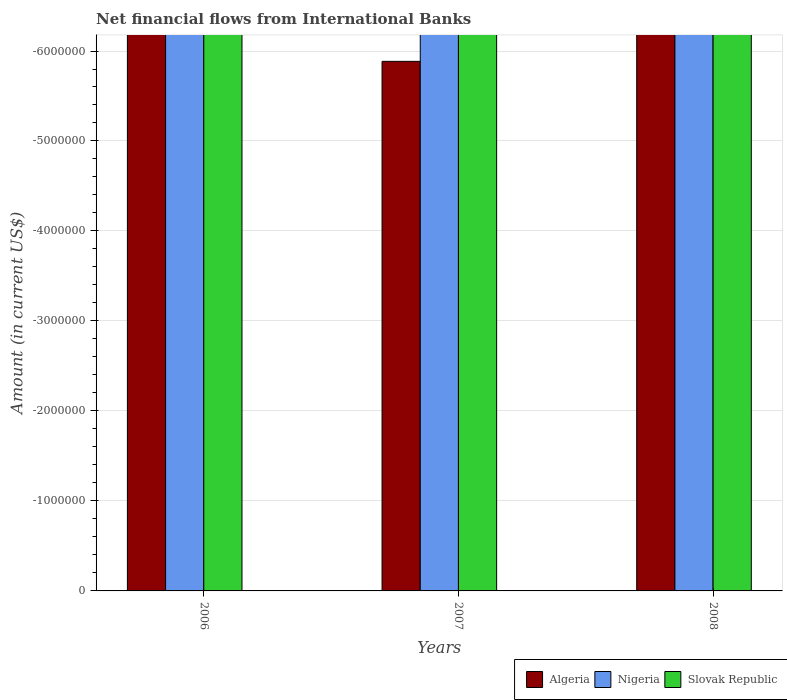How many bars are there on the 3rd tick from the right?
Offer a terse response. 0. What is the label of the 3rd group of bars from the left?
Your response must be concise. 2008. In how many cases, is the number of bars for a given year not equal to the number of legend labels?
Your answer should be very brief. 3. Across all years, what is the minimum net financial aid flows in Nigeria?
Ensure brevity in your answer.  0. In how many years, is the net financial aid flows in Slovak Republic greater than the average net financial aid flows in Slovak Republic taken over all years?
Your answer should be very brief. 0. Are all the bars in the graph horizontal?
Ensure brevity in your answer.  No. What is the difference between two consecutive major ticks on the Y-axis?
Give a very brief answer. 1.00e+06. Does the graph contain grids?
Offer a very short reply. Yes. How many legend labels are there?
Ensure brevity in your answer.  3. What is the title of the graph?
Provide a short and direct response. Net financial flows from International Banks. Does "St. Lucia" appear as one of the legend labels in the graph?
Ensure brevity in your answer.  No. What is the label or title of the X-axis?
Your answer should be very brief. Years. What is the label or title of the Y-axis?
Ensure brevity in your answer.  Amount (in current US$). What is the Amount (in current US$) of Algeria in 2007?
Ensure brevity in your answer.  0. What is the Amount (in current US$) of Slovak Republic in 2007?
Give a very brief answer. 0. What is the Amount (in current US$) of Algeria in 2008?
Provide a short and direct response. 0. What is the Amount (in current US$) of Slovak Republic in 2008?
Provide a succinct answer. 0. What is the total Amount (in current US$) of Slovak Republic in the graph?
Offer a terse response. 0. What is the average Amount (in current US$) in Nigeria per year?
Provide a succinct answer. 0. 